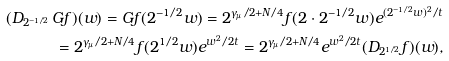<formula> <loc_0><loc_0><loc_500><loc_500>( D _ { 2 ^ { - 1 / 2 } } \, G f ) ( w ) = G f ( 2 ^ { - 1 / 2 } w ) = 2 ^ { \gamma _ { \mu } / 2 + N / 4 } f ( 2 \cdot 2 ^ { - 1 / 2 } w ) e ^ { ( 2 ^ { - 1 / 2 } w ) ^ { 2 } / t } \\ = 2 ^ { \gamma _ { \mu } / 2 + N / 4 } f ( 2 ^ { 1 / 2 } w ) e ^ { w ^ { 2 } / 2 t } = 2 ^ { \gamma _ { \mu } / 2 + N / 4 } e ^ { w ^ { 2 } / 2 t } ( D _ { 2 ^ { 1 / 2 } } f ) ( w ) ,</formula> 